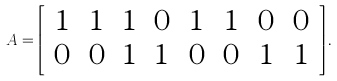Convert formula to latex. <formula><loc_0><loc_0><loc_500><loc_500>A = \left [ \begin{array} { c c c c c c c c } 1 & 1 & 1 & 0 & 1 & 1 & 0 & 0 \\ 0 & 0 & 1 & 1 & 0 & 0 & 1 & 1 \end{array} \right ] .</formula> 